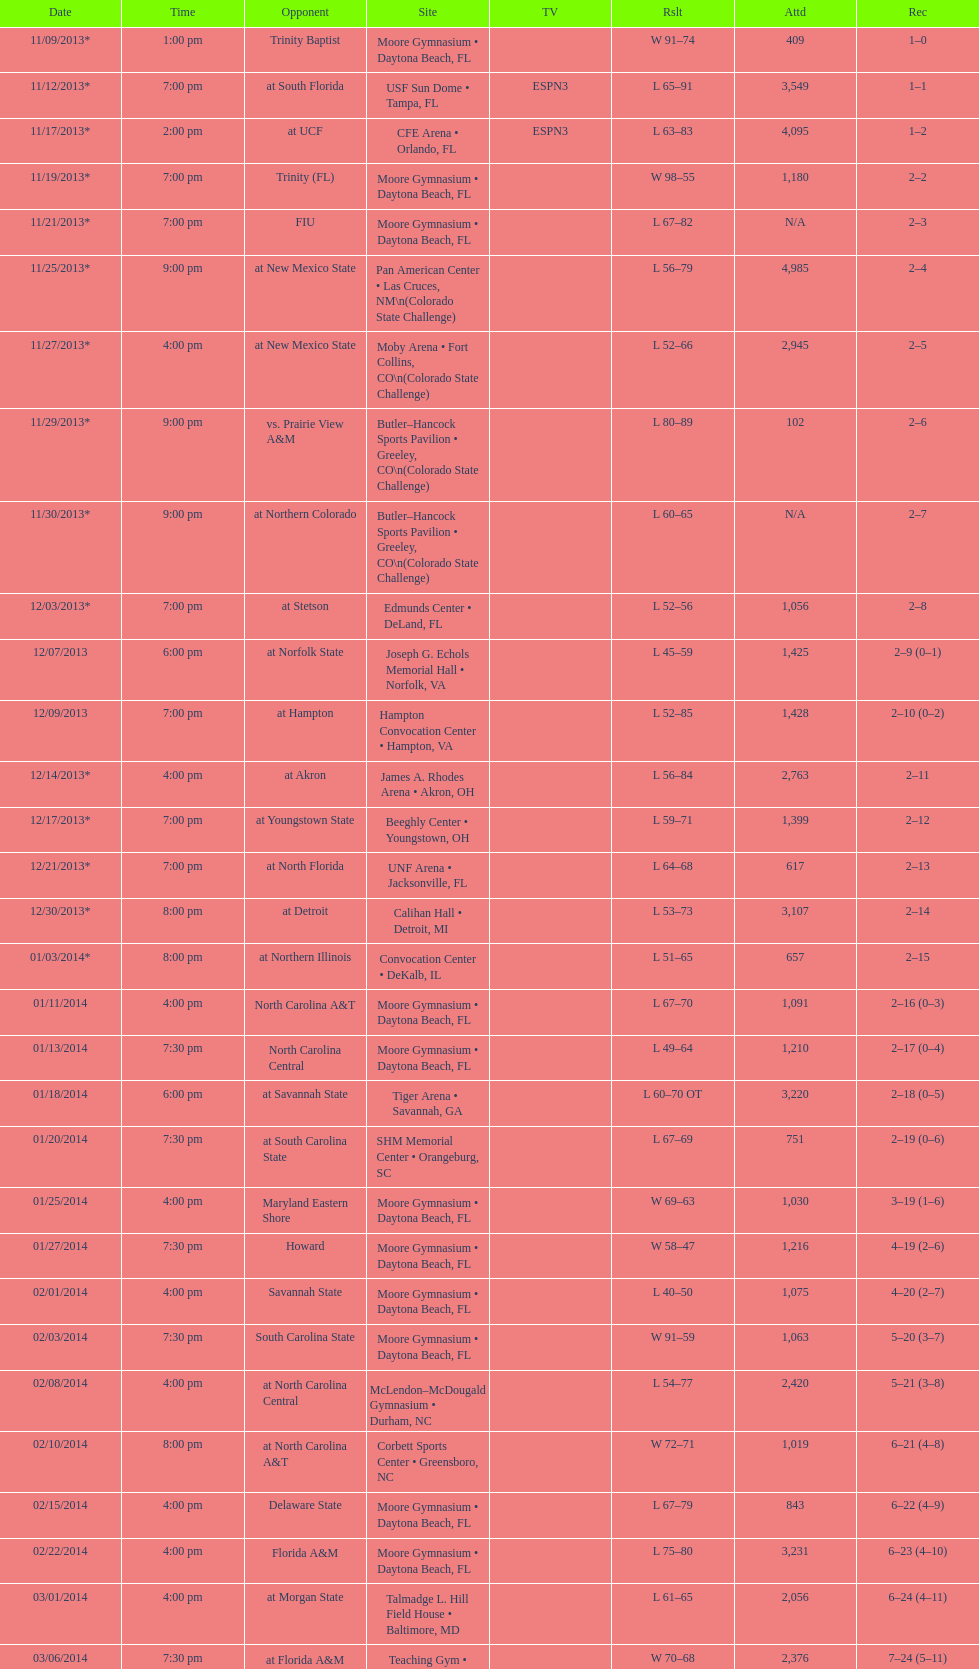How much larger was the attendance on 11/25/2013 than 12/21/2013? 4368. 